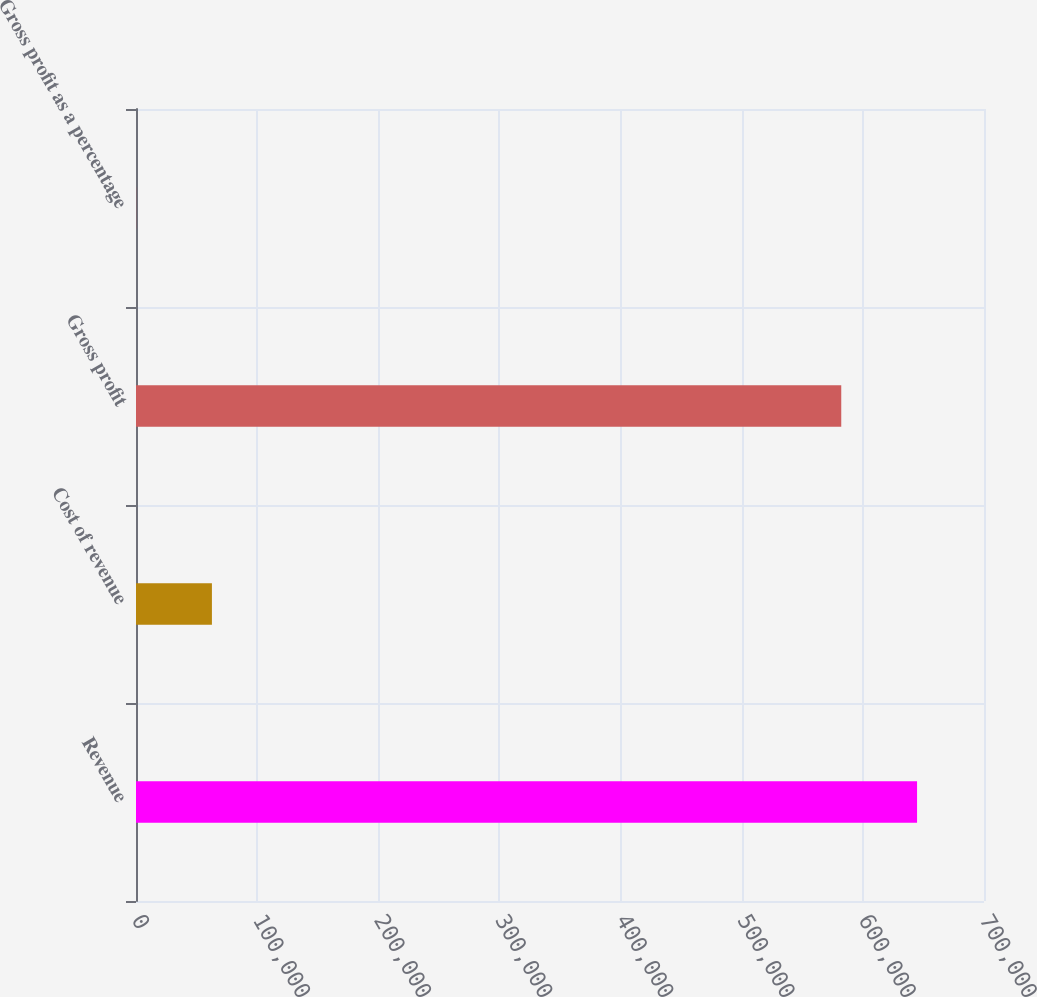<chart> <loc_0><loc_0><loc_500><loc_500><bar_chart><fcel>Revenue<fcel>Cost of revenue<fcel>Gross profit<fcel>Gross profit as a percentage<nl><fcel>644744<fcel>62667.3<fcel>582170<fcel>93<nl></chart> 